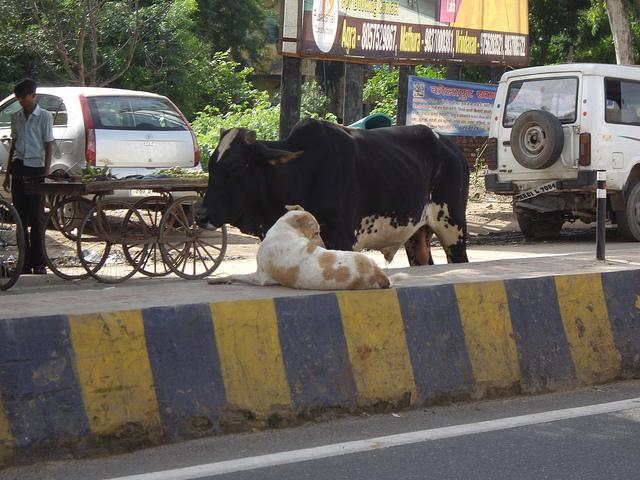What is known as the best cut of meat from the largest animal? Please explain your reasoning. filet mignon. The largest animal is a cow as identified by the size, shape and color. answer a is known to be a top choice cut of meat from this animal. 